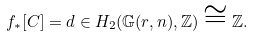<formula> <loc_0><loc_0><loc_500><loc_500>f _ { \ast } [ C ] = d \in H _ { 2 } ( \mathbb { G } ( r , n ) , \mathbb { Z } ) \cong \mathbb { Z } .</formula> 